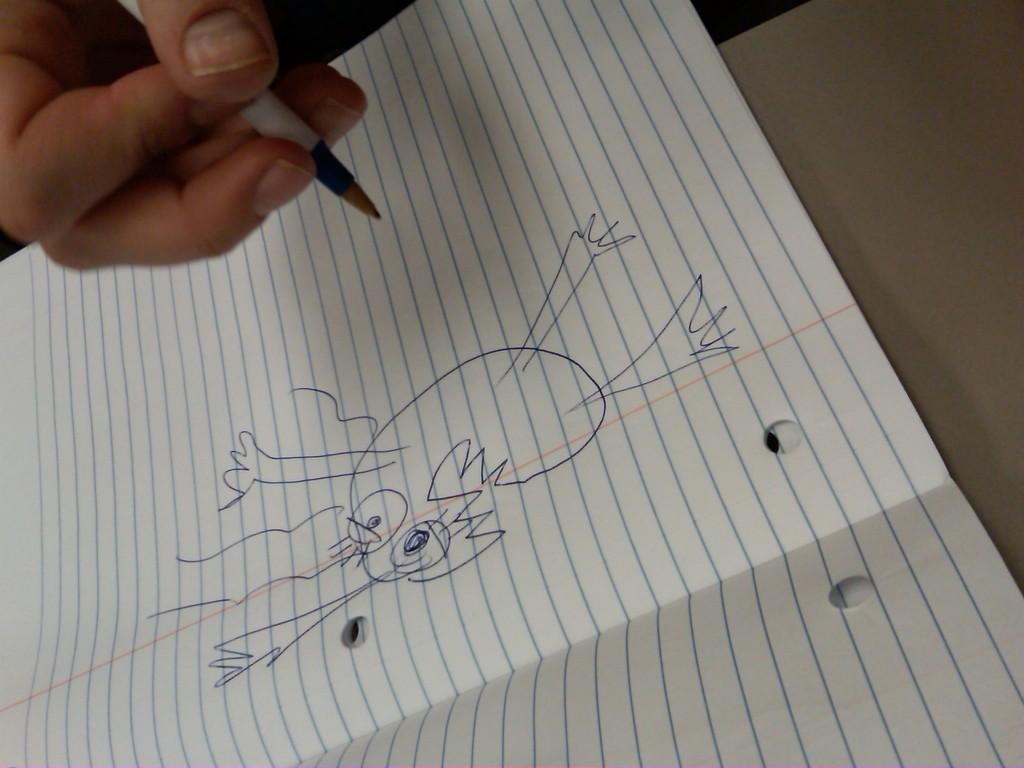What is the person in the image doing? The person is holding a pen. What is the person holding the pen near? There is a paper in the image. What can be seen on the paper? The paper has a drawing on it. What type of crayon is the person using to color the drawing on the paper? There is no crayon mentioned or visible in the image; the person is holding a pen. How many buckets of water are present in the image? There are no buckets of water present in the image. 